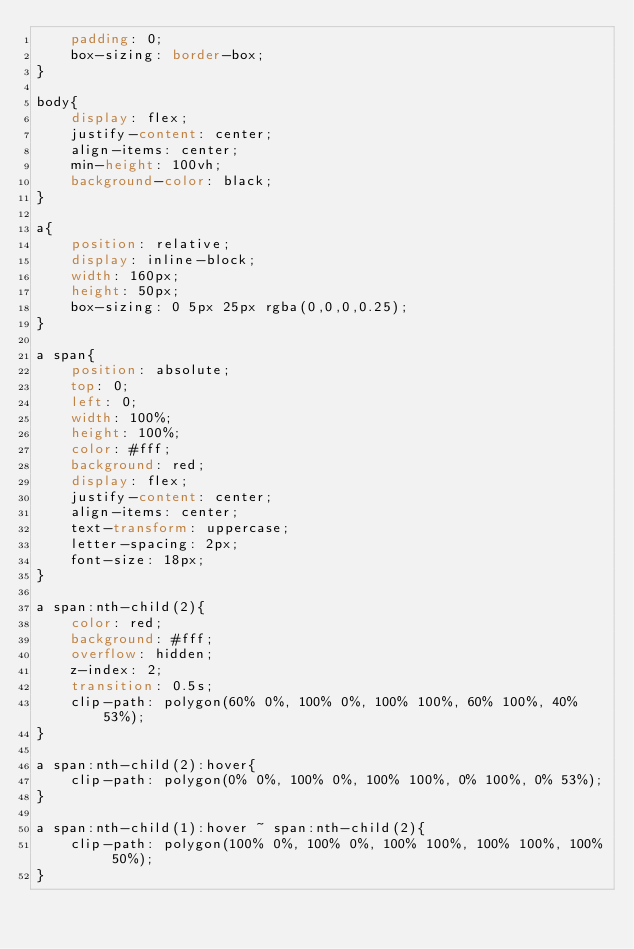Convert code to text. <code><loc_0><loc_0><loc_500><loc_500><_CSS_>    padding: 0;
    box-sizing: border-box;
}

body{
    display: flex;
    justify-content: center;
    align-items: center;
    min-height: 100vh;
    background-color: black;
}

a{
    position: relative;
    display: inline-block;
    width: 160px;
    height: 50px;
    box-sizing: 0 5px 25px rgba(0,0,0,0.25);
}

a span{
    position: absolute;
    top: 0;
    left: 0;
    width: 100%;
    height: 100%;
    color: #fff;
    background: red;
    display: flex;
    justify-content: center;
    align-items: center;
    text-transform: uppercase;
    letter-spacing: 2px;
    font-size: 18px;
}

a span:nth-child(2){
    color: red;
    background: #fff;
    overflow: hidden;
    z-index: 2;
    transition: 0.5s;
    clip-path: polygon(60% 0%, 100% 0%, 100% 100%, 60% 100%, 40% 53%);
}

a span:nth-child(2):hover{
    clip-path: polygon(0% 0%, 100% 0%, 100% 100%, 0% 100%, 0% 53%);
}

a span:nth-child(1):hover ~ span:nth-child(2){
    clip-path: polygon(100% 0%, 100% 0%, 100% 100%, 100% 100%, 100% 50%);
}</code> 